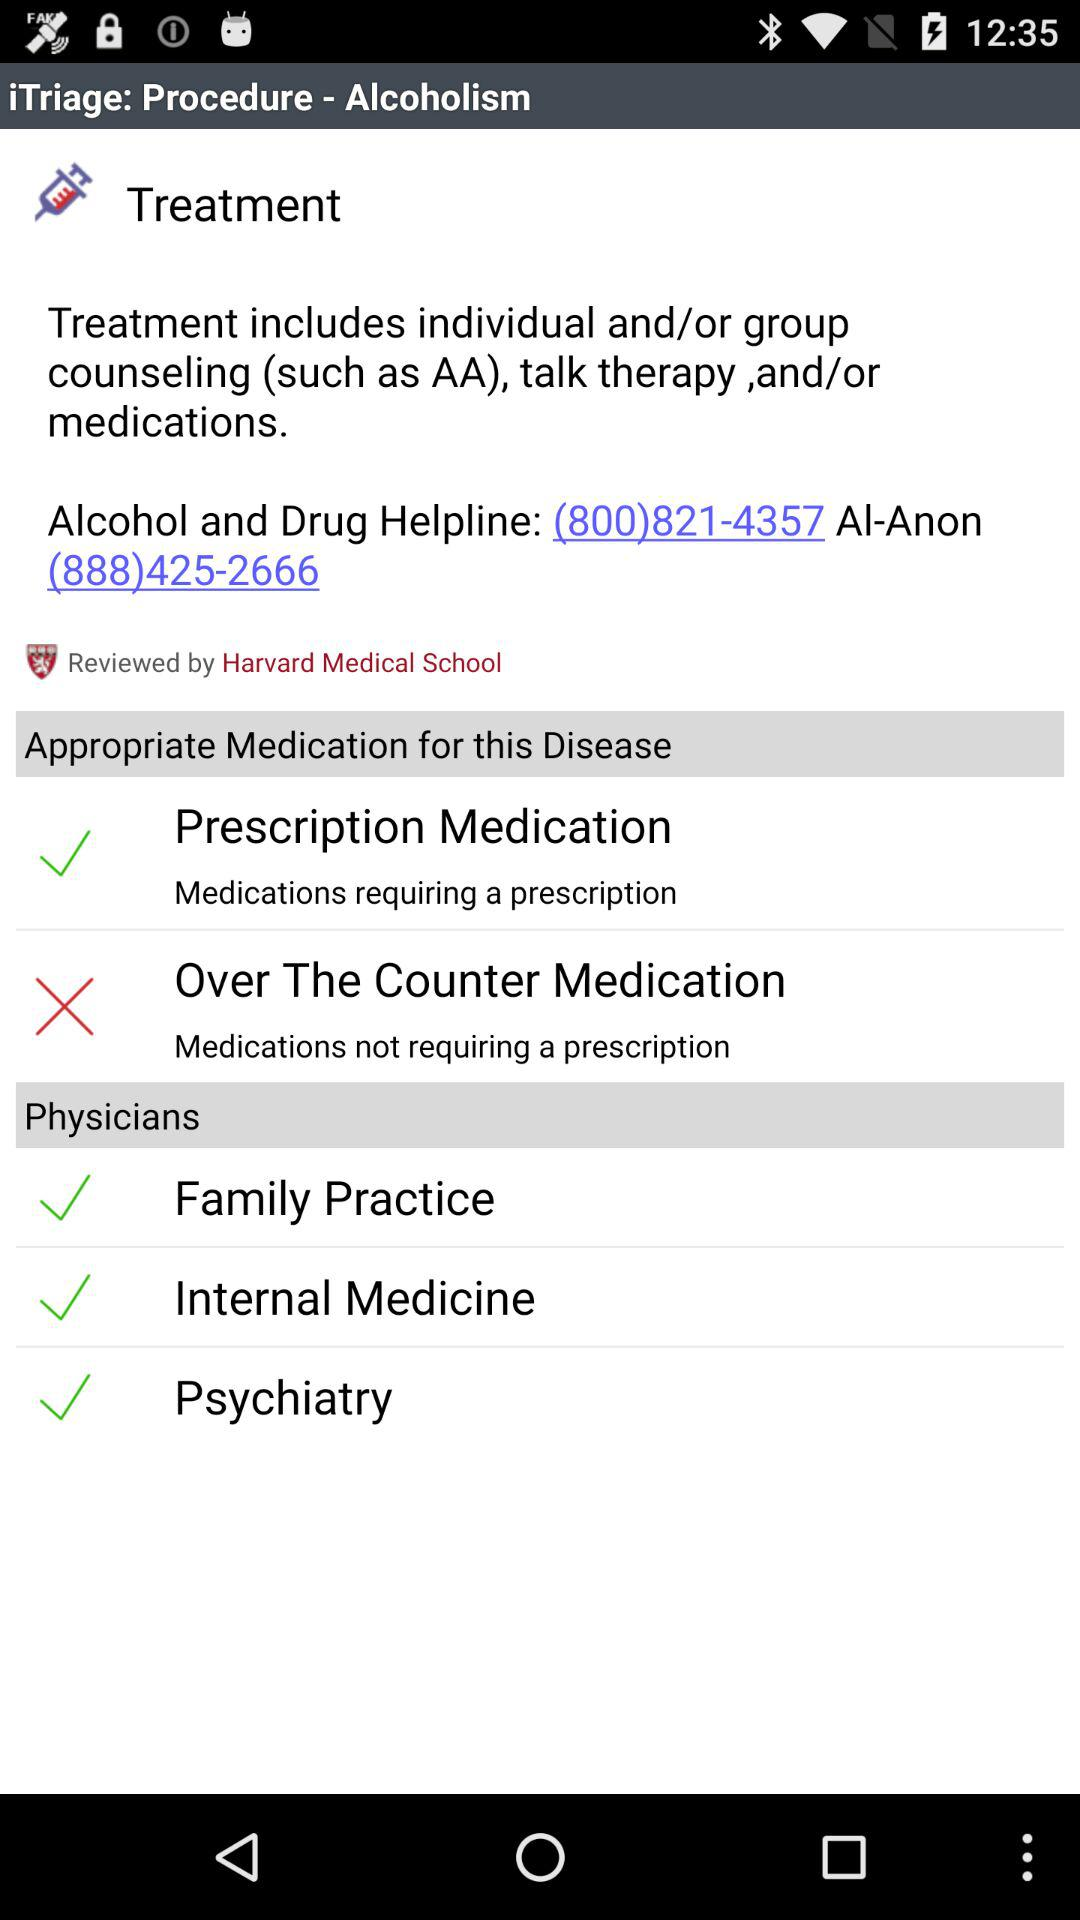Which options are there in "Physicians"? The options are "Family Practice", "Internal Medicine" and "Psychiatry". 